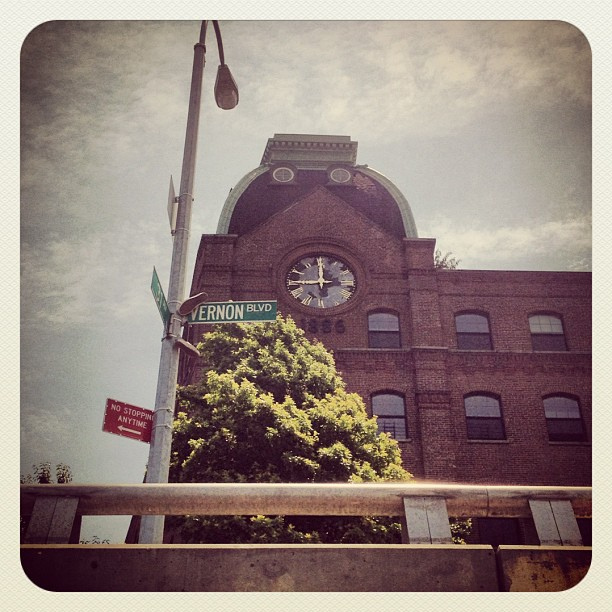What kind of material is the building made out?
Answer the question using a single word or phrase. Brick 